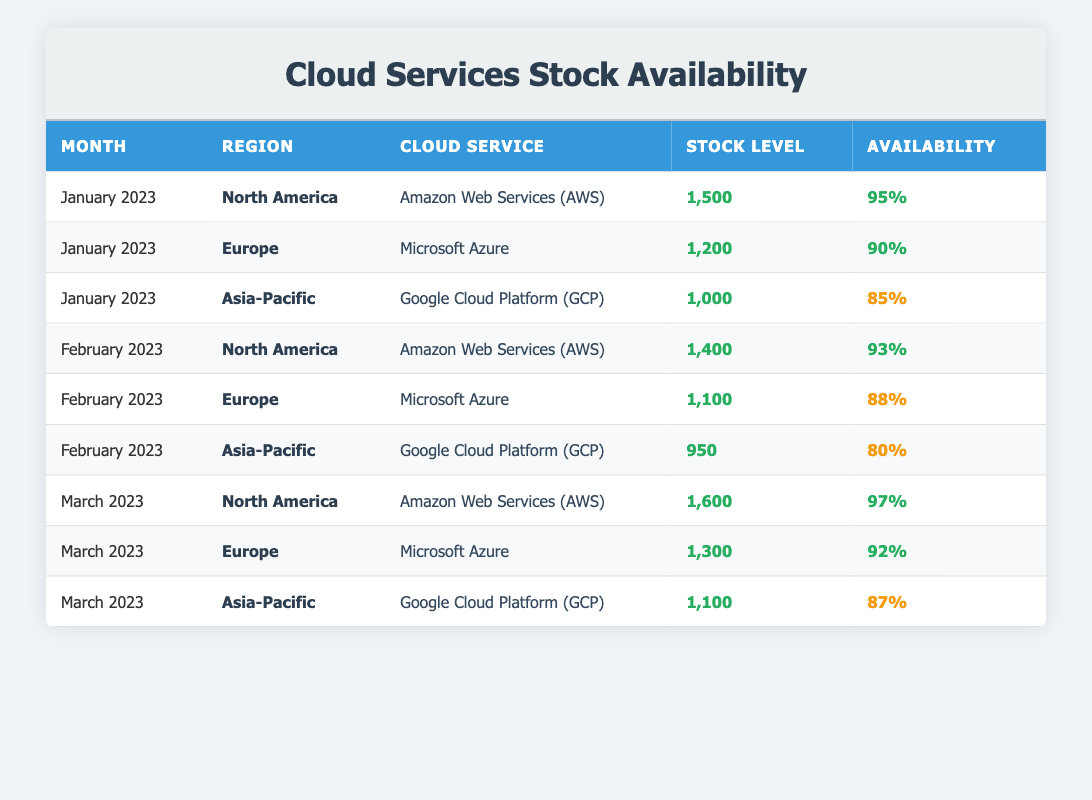What is the stock level of Amazon Web Services (AWS) in North America for March 2023? The table lists the stock level for Amazon Web Services (AWS) in North America under March 2023, which is clearly shown to be 1,600.
Answer: 1,600 What is the availability percentage for Microsoft Azure in Europe for February 2023? Looking at the table, the availability percentage for Microsoft Azure in Europe for February 2023 is recorded as 88%.
Answer: 88% Did the stock level for Google Cloud Platform (GCP) in Asia-Pacific increase from January to March 2023? By comparing the stock levels: January has 1,000, February has 950, and March has 1,100. Since 950 is lower than 1,000 and increases to 1,100 in March, the stock level does increase from January to March.
Answer: Yes What is the average stock level for all cloud services in North America across the three months? The stock levels for North America are: 1,500 (January) + 1,400 (February) + 1,600 (March) = 4,500. Dividing by 3 months gives an average of 4,500/3 = 1,500.
Answer: 1,500 Is the availability percentage for Google Cloud Platform (GCP) in Asia-Pacific ever above 85%? The availability percentages for Google Cloud Platform (GCP) in Asia-Pacific are 85% in January, 80% in February, and 87% in March. Since 87% is above 85%, the answer is yes.
Answer: Yes What was the percentage decrease in stock level for Microsoft Azure in Europe from January to February 2023? The stock levels are 1,200 in January and drop to 1,100 in February. The decrease is 1,200 - 1,100 = 100. To find the percentage decrease: (100/1,200) * 100 = 8.33%.
Answer: 8.33% Which cloud service had the highest availability percentage in March 2023? In March 2023, the availability percentages are: AWS at 97%, Microsoft Azure at 92%, and GCP at 87%. The highest percentage is 97%, from AWS.
Answer: Amazon Web Services (AWS) What is the total stock level for all cloud services in Europe over the three months? The stock levels for Europe are 1,200 (January) + 1,100 (February) + 1,300 (March) = 3,600. This is the total stock level for all services in Europe.
Answer: 3,600 Did the availability percentage for Amazon Web Services (AWS) decrease from January to February in North America? Checking the availability percentages for AWS in North America: January is 95% and February is 93%. Since 93% is less than 95%, there is a decrease.
Answer: Yes 